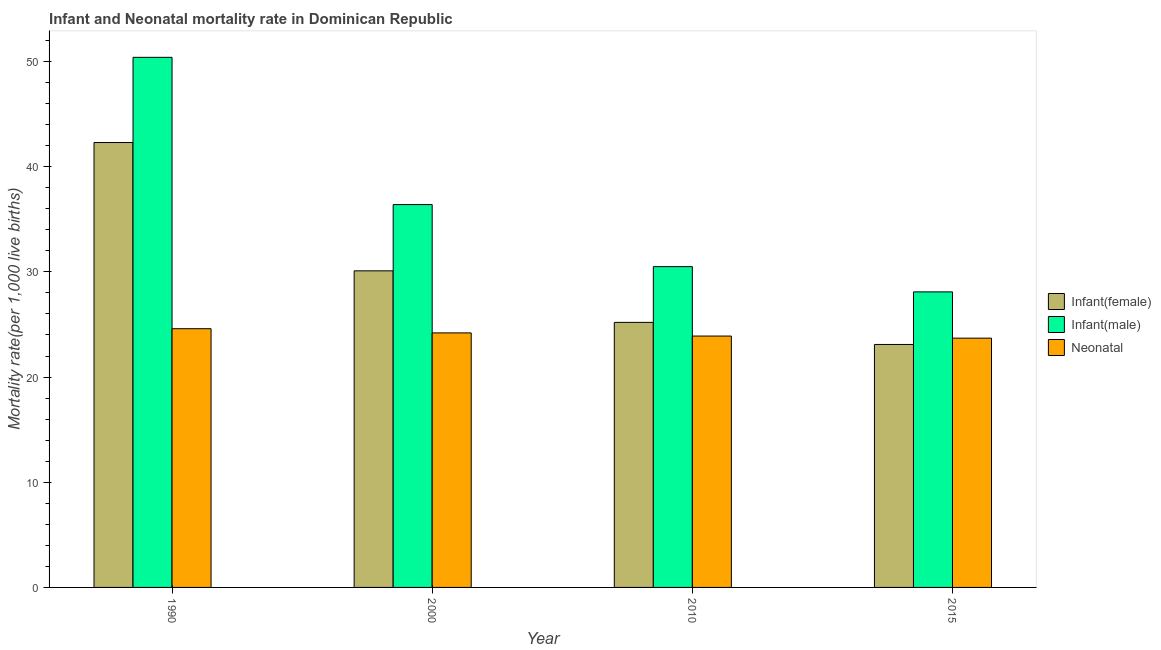How many different coloured bars are there?
Your answer should be compact. 3. How many groups of bars are there?
Make the answer very short. 4. Are the number of bars per tick equal to the number of legend labels?
Provide a short and direct response. Yes. How many bars are there on the 4th tick from the left?
Your response must be concise. 3. What is the label of the 3rd group of bars from the left?
Make the answer very short. 2010. In how many cases, is the number of bars for a given year not equal to the number of legend labels?
Provide a succinct answer. 0. What is the neonatal mortality rate in 2010?
Provide a succinct answer. 23.9. Across all years, what is the maximum infant mortality rate(male)?
Provide a succinct answer. 50.4. Across all years, what is the minimum infant mortality rate(female)?
Provide a succinct answer. 23.1. In which year was the infant mortality rate(female) maximum?
Your answer should be very brief. 1990. In which year was the neonatal mortality rate minimum?
Give a very brief answer. 2015. What is the total neonatal mortality rate in the graph?
Keep it short and to the point. 96.4. What is the difference between the infant mortality rate(male) in 2000 and that in 2010?
Give a very brief answer. 5.9. What is the difference between the infant mortality rate(male) in 2010 and the neonatal mortality rate in 1990?
Ensure brevity in your answer.  -19.9. What is the average infant mortality rate(female) per year?
Provide a short and direct response. 30.18. In the year 1990, what is the difference between the neonatal mortality rate and infant mortality rate(female)?
Your answer should be compact. 0. What is the ratio of the infant mortality rate(female) in 2000 to that in 2010?
Offer a terse response. 1.19. What is the difference between the highest and the second highest infant mortality rate(female)?
Your answer should be very brief. 12.2. What is the difference between the highest and the lowest infant mortality rate(female)?
Keep it short and to the point. 19.2. In how many years, is the neonatal mortality rate greater than the average neonatal mortality rate taken over all years?
Make the answer very short. 2. Is the sum of the infant mortality rate(female) in 1990 and 2010 greater than the maximum neonatal mortality rate across all years?
Offer a terse response. Yes. What does the 2nd bar from the left in 2015 represents?
Your response must be concise. Infant(male). What does the 1st bar from the right in 2010 represents?
Ensure brevity in your answer.  Neonatal . Is it the case that in every year, the sum of the infant mortality rate(female) and infant mortality rate(male) is greater than the neonatal mortality rate?
Keep it short and to the point. Yes. Are all the bars in the graph horizontal?
Ensure brevity in your answer.  No. What is the difference between two consecutive major ticks on the Y-axis?
Your response must be concise. 10. Are the values on the major ticks of Y-axis written in scientific E-notation?
Offer a terse response. No. Does the graph contain any zero values?
Make the answer very short. No. Where does the legend appear in the graph?
Ensure brevity in your answer.  Center right. What is the title of the graph?
Provide a short and direct response. Infant and Neonatal mortality rate in Dominican Republic. What is the label or title of the Y-axis?
Give a very brief answer. Mortality rate(per 1,0 live births). What is the Mortality rate(per 1,000 live births) of Infant(female) in 1990?
Keep it short and to the point. 42.3. What is the Mortality rate(per 1,000 live births) of Infant(male) in 1990?
Offer a very short reply. 50.4. What is the Mortality rate(per 1,000 live births) of Neonatal  in 1990?
Offer a very short reply. 24.6. What is the Mortality rate(per 1,000 live births) of Infant(female) in 2000?
Offer a terse response. 30.1. What is the Mortality rate(per 1,000 live births) of Infant(male) in 2000?
Offer a terse response. 36.4. What is the Mortality rate(per 1,000 live births) in Neonatal  in 2000?
Offer a terse response. 24.2. What is the Mortality rate(per 1,000 live births) in Infant(female) in 2010?
Make the answer very short. 25.2. What is the Mortality rate(per 1,000 live births) in Infant(male) in 2010?
Provide a short and direct response. 30.5. What is the Mortality rate(per 1,000 live births) in Neonatal  in 2010?
Make the answer very short. 23.9. What is the Mortality rate(per 1,000 live births) in Infant(female) in 2015?
Provide a succinct answer. 23.1. What is the Mortality rate(per 1,000 live births) of Infant(male) in 2015?
Provide a short and direct response. 28.1. What is the Mortality rate(per 1,000 live births) in Neonatal  in 2015?
Your answer should be compact. 23.7. Across all years, what is the maximum Mortality rate(per 1,000 live births) in Infant(female)?
Provide a succinct answer. 42.3. Across all years, what is the maximum Mortality rate(per 1,000 live births) in Infant(male)?
Offer a terse response. 50.4. Across all years, what is the maximum Mortality rate(per 1,000 live births) of Neonatal ?
Offer a very short reply. 24.6. Across all years, what is the minimum Mortality rate(per 1,000 live births) of Infant(female)?
Your answer should be compact. 23.1. Across all years, what is the minimum Mortality rate(per 1,000 live births) of Infant(male)?
Offer a very short reply. 28.1. Across all years, what is the minimum Mortality rate(per 1,000 live births) of Neonatal ?
Provide a short and direct response. 23.7. What is the total Mortality rate(per 1,000 live births) of Infant(female) in the graph?
Keep it short and to the point. 120.7. What is the total Mortality rate(per 1,000 live births) of Infant(male) in the graph?
Keep it short and to the point. 145.4. What is the total Mortality rate(per 1,000 live births) of Neonatal  in the graph?
Ensure brevity in your answer.  96.4. What is the difference between the Mortality rate(per 1,000 live births) of Infant(female) in 1990 and that in 2010?
Your response must be concise. 17.1. What is the difference between the Mortality rate(per 1,000 live births) of Infant(male) in 1990 and that in 2015?
Your answer should be compact. 22.3. What is the difference between the Mortality rate(per 1,000 live births) of Neonatal  in 1990 and that in 2015?
Keep it short and to the point. 0.9. What is the difference between the Mortality rate(per 1,000 live births) of Infant(male) in 2000 and that in 2015?
Ensure brevity in your answer.  8.3. What is the difference between the Mortality rate(per 1,000 live births) of Neonatal  in 2000 and that in 2015?
Keep it short and to the point. 0.5. What is the difference between the Mortality rate(per 1,000 live births) in Infant(male) in 2010 and that in 2015?
Offer a very short reply. 2.4. What is the difference between the Mortality rate(per 1,000 live births) in Infant(female) in 1990 and the Mortality rate(per 1,000 live births) in Infant(male) in 2000?
Your answer should be compact. 5.9. What is the difference between the Mortality rate(per 1,000 live births) of Infant(female) in 1990 and the Mortality rate(per 1,000 live births) of Neonatal  in 2000?
Your answer should be compact. 18.1. What is the difference between the Mortality rate(per 1,000 live births) in Infant(male) in 1990 and the Mortality rate(per 1,000 live births) in Neonatal  in 2000?
Offer a terse response. 26.2. What is the difference between the Mortality rate(per 1,000 live births) of Infant(female) in 1990 and the Mortality rate(per 1,000 live births) of Infant(male) in 2010?
Give a very brief answer. 11.8. What is the difference between the Mortality rate(per 1,000 live births) in Infant(female) in 1990 and the Mortality rate(per 1,000 live births) in Neonatal  in 2010?
Offer a terse response. 18.4. What is the difference between the Mortality rate(per 1,000 live births) in Infant(male) in 1990 and the Mortality rate(per 1,000 live births) in Neonatal  in 2010?
Keep it short and to the point. 26.5. What is the difference between the Mortality rate(per 1,000 live births) in Infant(female) in 1990 and the Mortality rate(per 1,000 live births) in Neonatal  in 2015?
Provide a succinct answer. 18.6. What is the difference between the Mortality rate(per 1,000 live births) in Infant(male) in 1990 and the Mortality rate(per 1,000 live births) in Neonatal  in 2015?
Give a very brief answer. 26.7. What is the difference between the Mortality rate(per 1,000 live births) in Infant(female) in 2000 and the Mortality rate(per 1,000 live births) in Infant(male) in 2010?
Your response must be concise. -0.4. What is the difference between the Mortality rate(per 1,000 live births) in Infant(male) in 2000 and the Mortality rate(per 1,000 live births) in Neonatal  in 2010?
Provide a succinct answer. 12.5. What is the difference between the Mortality rate(per 1,000 live births) in Infant(female) in 2000 and the Mortality rate(per 1,000 live births) in Neonatal  in 2015?
Your response must be concise. 6.4. What is the difference between the Mortality rate(per 1,000 live births) of Infant(female) in 2010 and the Mortality rate(per 1,000 live births) of Infant(male) in 2015?
Your answer should be compact. -2.9. What is the difference between the Mortality rate(per 1,000 live births) of Infant(male) in 2010 and the Mortality rate(per 1,000 live births) of Neonatal  in 2015?
Your response must be concise. 6.8. What is the average Mortality rate(per 1,000 live births) of Infant(female) per year?
Offer a terse response. 30.18. What is the average Mortality rate(per 1,000 live births) in Infant(male) per year?
Ensure brevity in your answer.  36.35. What is the average Mortality rate(per 1,000 live births) of Neonatal  per year?
Offer a terse response. 24.1. In the year 1990, what is the difference between the Mortality rate(per 1,000 live births) of Infant(female) and Mortality rate(per 1,000 live births) of Infant(male)?
Provide a short and direct response. -8.1. In the year 1990, what is the difference between the Mortality rate(per 1,000 live births) of Infant(male) and Mortality rate(per 1,000 live births) of Neonatal ?
Make the answer very short. 25.8. In the year 2000, what is the difference between the Mortality rate(per 1,000 live births) of Infant(female) and Mortality rate(per 1,000 live births) of Neonatal ?
Offer a very short reply. 5.9. In the year 2000, what is the difference between the Mortality rate(per 1,000 live births) of Infant(male) and Mortality rate(per 1,000 live births) of Neonatal ?
Offer a terse response. 12.2. In the year 2015, what is the difference between the Mortality rate(per 1,000 live births) in Infant(female) and Mortality rate(per 1,000 live births) in Neonatal ?
Give a very brief answer. -0.6. What is the ratio of the Mortality rate(per 1,000 live births) of Infant(female) in 1990 to that in 2000?
Keep it short and to the point. 1.41. What is the ratio of the Mortality rate(per 1,000 live births) of Infant(male) in 1990 to that in 2000?
Make the answer very short. 1.38. What is the ratio of the Mortality rate(per 1,000 live births) in Neonatal  in 1990 to that in 2000?
Your answer should be very brief. 1.02. What is the ratio of the Mortality rate(per 1,000 live births) of Infant(female) in 1990 to that in 2010?
Your answer should be very brief. 1.68. What is the ratio of the Mortality rate(per 1,000 live births) of Infant(male) in 1990 to that in 2010?
Provide a succinct answer. 1.65. What is the ratio of the Mortality rate(per 1,000 live births) in Neonatal  in 1990 to that in 2010?
Ensure brevity in your answer.  1.03. What is the ratio of the Mortality rate(per 1,000 live births) of Infant(female) in 1990 to that in 2015?
Offer a terse response. 1.83. What is the ratio of the Mortality rate(per 1,000 live births) in Infant(male) in 1990 to that in 2015?
Provide a succinct answer. 1.79. What is the ratio of the Mortality rate(per 1,000 live births) of Neonatal  in 1990 to that in 2015?
Give a very brief answer. 1.04. What is the ratio of the Mortality rate(per 1,000 live births) of Infant(female) in 2000 to that in 2010?
Provide a succinct answer. 1.19. What is the ratio of the Mortality rate(per 1,000 live births) in Infant(male) in 2000 to that in 2010?
Ensure brevity in your answer.  1.19. What is the ratio of the Mortality rate(per 1,000 live births) in Neonatal  in 2000 to that in 2010?
Offer a terse response. 1.01. What is the ratio of the Mortality rate(per 1,000 live births) of Infant(female) in 2000 to that in 2015?
Offer a very short reply. 1.3. What is the ratio of the Mortality rate(per 1,000 live births) of Infant(male) in 2000 to that in 2015?
Ensure brevity in your answer.  1.3. What is the ratio of the Mortality rate(per 1,000 live births) of Neonatal  in 2000 to that in 2015?
Provide a short and direct response. 1.02. What is the ratio of the Mortality rate(per 1,000 live births) of Infant(female) in 2010 to that in 2015?
Your answer should be compact. 1.09. What is the ratio of the Mortality rate(per 1,000 live births) in Infant(male) in 2010 to that in 2015?
Offer a terse response. 1.09. What is the ratio of the Mortality rate(per 1,000 live births) of Neonatal  in 2010 to that in 2015?
Your response must be concise. 1.01. What is the difference between the highest and the second highest Mortality rate(per 1,000 live births) in Infant(female)?
Make the answer very short. 12.2. What is the difference between the highest and the lowest Mortality rate(per 1,000 live births) of Infant(female)?
Your response must be concise. 19.2. What is the difference between the highest and the lowest Mortality rate(per 1,000 live births) in Infant(male)?
Offer a terse response. 22.3. What is the difference between the highest and the lowest Mortality rate(per 1,000 live births) in Neonatal ?
Your answer should be compact. 0.9. 